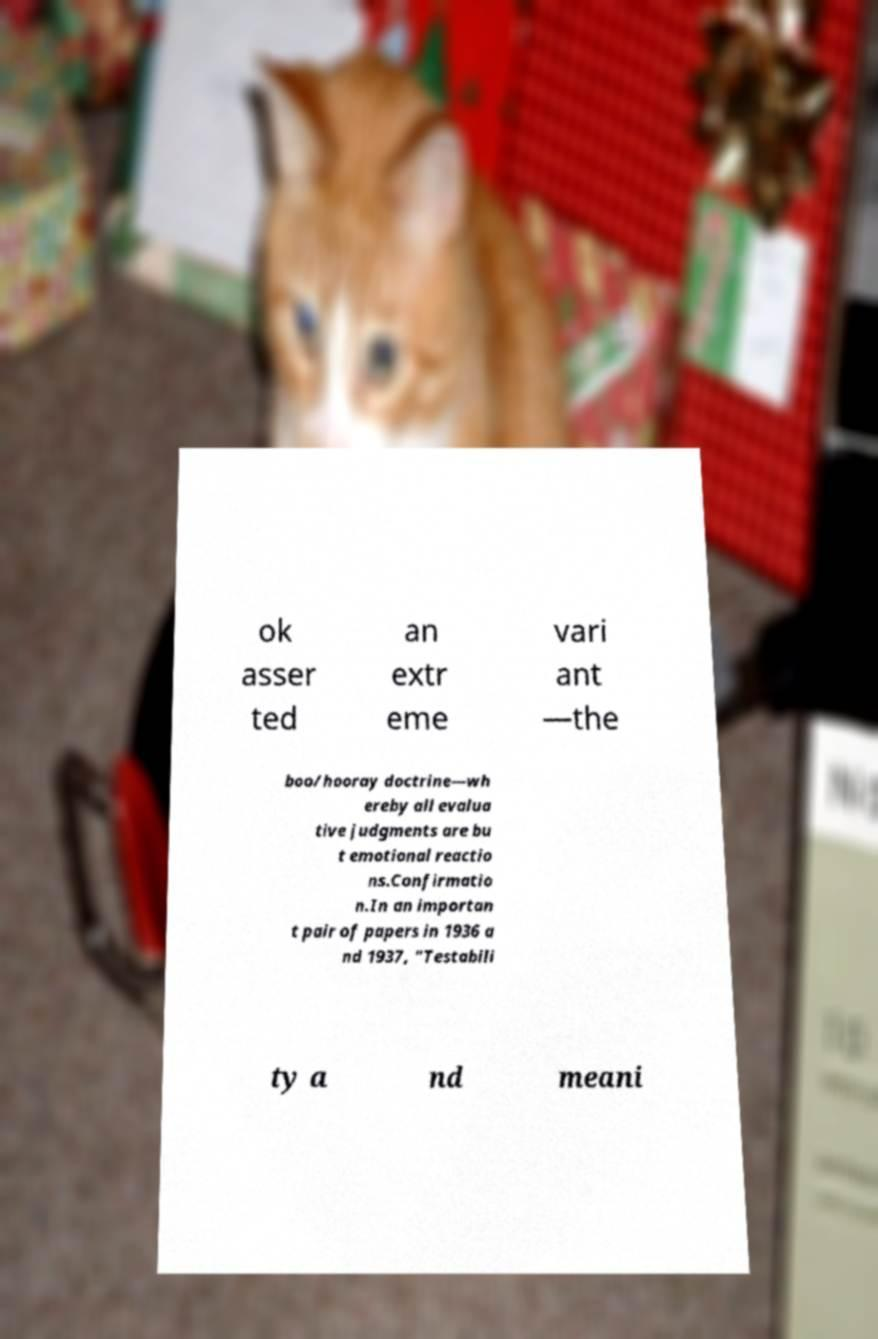Could you assist in decoding the text presented in this image and type it out clearly? ok asser ted an extr eme vari ant —the boo/hooray doctrine—wh ereby all evalua tive judgments are bu t emotional reactio ns.Confirmatio n.In an importan t pair of papers in 1936 a nd 1937, "Testabili ty a nd meani 